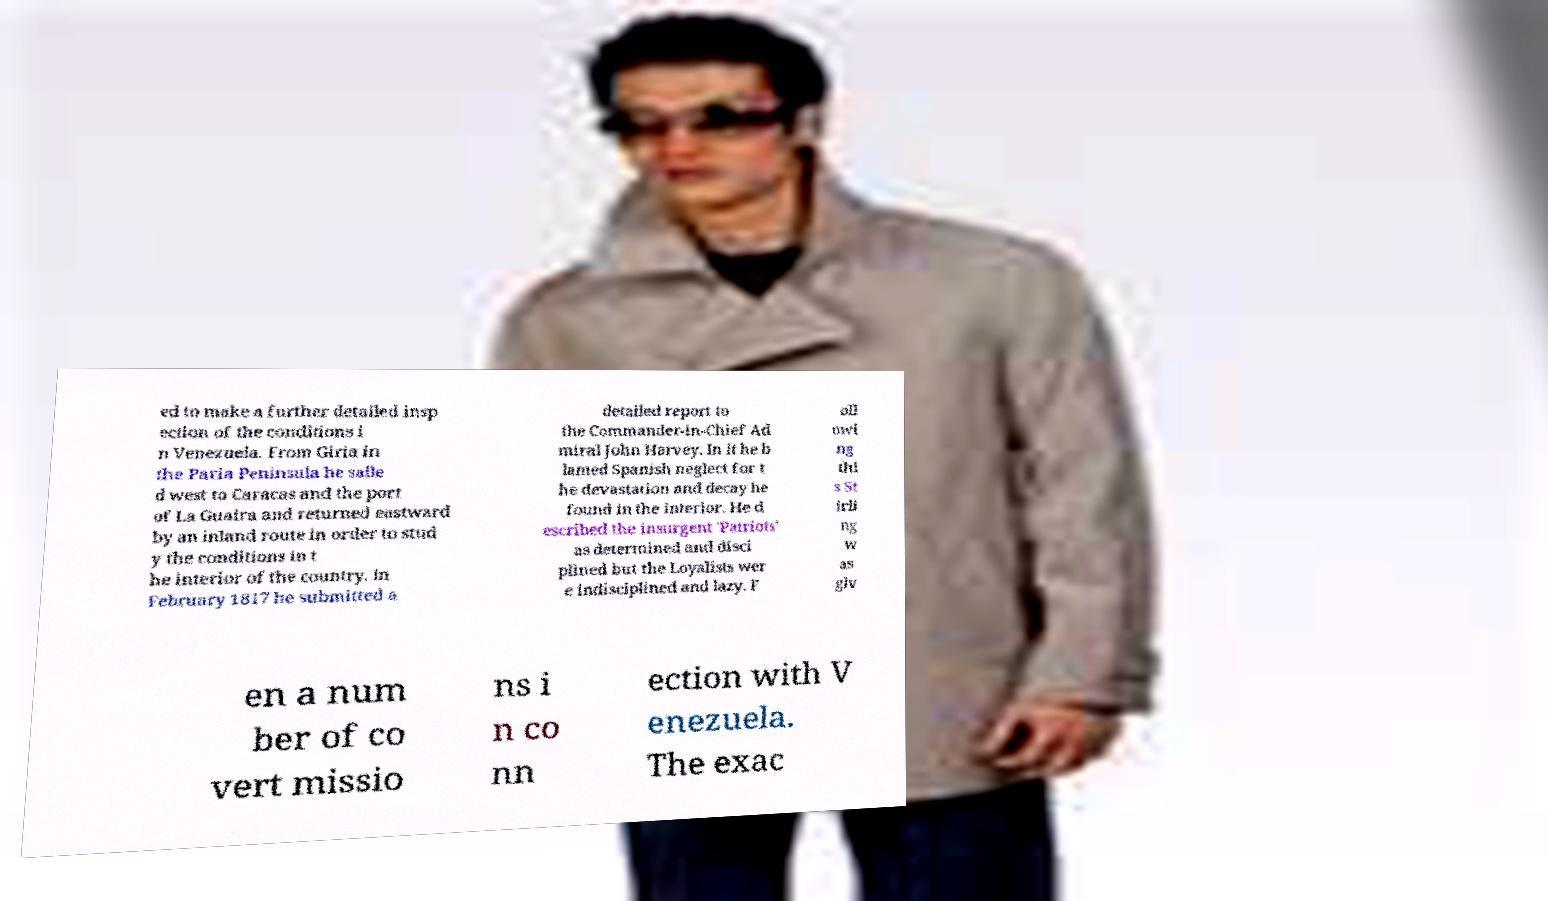What messages or text are displayed in this image? I need them in a readable, typed format. ed to make a further detailed insp ection of the conditions i n Venezuela. From Giria in the Paria Peninsula he saile d west to Caracas and the port of La Guaira and returned eastward by an inland route in order to stud y the conditions in t he interior of the country. In February 1817 he submitted a detailed report to the Commander-in-Chief Ad miral John Harvey. In it he b lamed Spanish neglect for t he devastation and decay he found in the interior. He d escribed the insurgent 'Patriots' as determined and disci plined but the Loyalists wer e indisciplined and lazy. F oll owi ng thi s St irli ng w as giv en a num ber of co vert missio ns i n co nn ection with V enezuela. The exac 